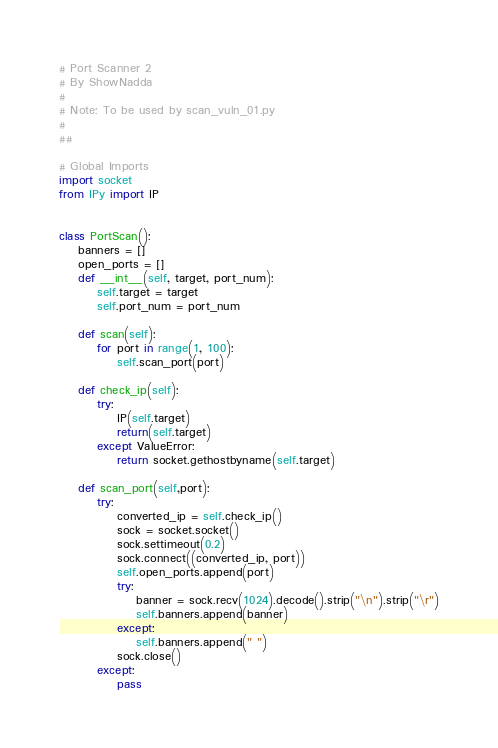<code> <loc_0><loc_0><loc_500><loc_500><_Python_># Port Scanner 2
# By ShowNadda
#
# Note: To be used by scan_vuln_01.py
#
##

# Global Imports
import socket
from IPy import IP


class PortScan():
    banners = []
    open_ports = []
    def __int__(self, target, port_num):
        self.target = target
        self.port_num = port_num

    def scan(self):
        for port in range(1, 100):
            self.scan_port(port)

    def check_ip(self):
        try:
            IP(self.target)
            return(self.target)
        except ValueError:
            return socket.gethostbyname(self.target)

    def scan_port(self,port):
        try:
            converted_ip = self.check_ip()
            sock = socket.socket()
            sock.settimeout(0.2)
            sock.connect((converted_ip, port))
            self.open_ports.append(port)
            try:
                banner = sock.recv(1024).decode().strip("\n").strip("\r")
                self.banners.append(banner)
            except:
                self.banners.append(" ")
            sock.close()
        except:
            pass
</code> 